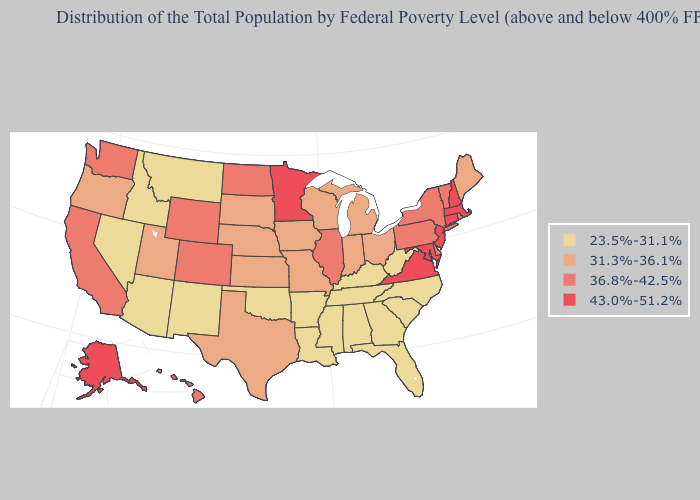What is the highest value in the USA?
Give a very brief answer. 43.0%-51.2%. Does the map have missing data?
Write a very short answer. No. Which states hav the highest value in the West?
Quick response, please. Alaska. Does Alaska have the lowest value in the West?
Give a very brief answer. No. Name the states that have a value in the range 31.3%-36.1%?
Write a very short answer. Indiana, Iowa, Kansas, Maine, Michigan, Missouri, Nebraska, Ohio, Oregon, South Dakota, Texas, Utah, Wisconsin. Which states have the highest value in the USA?
Short answer required. Alaska, Connecticut, Maryland, Massachusetts, Minnesota, New Hampshire, New Jersey, Virginia. Does Alaska have the highest value in the West?
Give a very brief answer. Yes. How many symbols are there in the legend?
Concise answer only. 4. Name the states that have a value in the range 36.8%-42.5%?
Write a very short answer. California, Colorado, Delaware, Hawaii, Illinois, New York, North Dakota, Pennsylvania, Rhode Island, Vermont, Washington, Wyoming. Among the states that border Connecticut , which have the highest value?
Short answer required. Massachusetts. Among the states that border Delaware , does Pennsylvania have the lowest value?
Be succinct. Yes. Name the states that have a value in the range 43.0%-51.2%?
Concise answer only. Alaska, Connecticut, Maryland, Massachusetts, Minnesota, New Hampshire, New Jersey, Virginia. Name the states that have a value in the range 43.0%-51.2%?
Be succinct. Alaska, Connecticut, Maryland, Massachusetts, Minnesota, New Hampshire, New Jersey, Virginia. Name the states that have a value in the range 36.8%-42.5%?
Be succinct. California, Colorado, Delaware, Hawaii, Illinois, New York, North Dakota, Pennsylvania, Rhode Island, Vermont, Washington, Wyoming. What is the value of Florida?
Give a very brief answer. 23.5%-31.1%. 